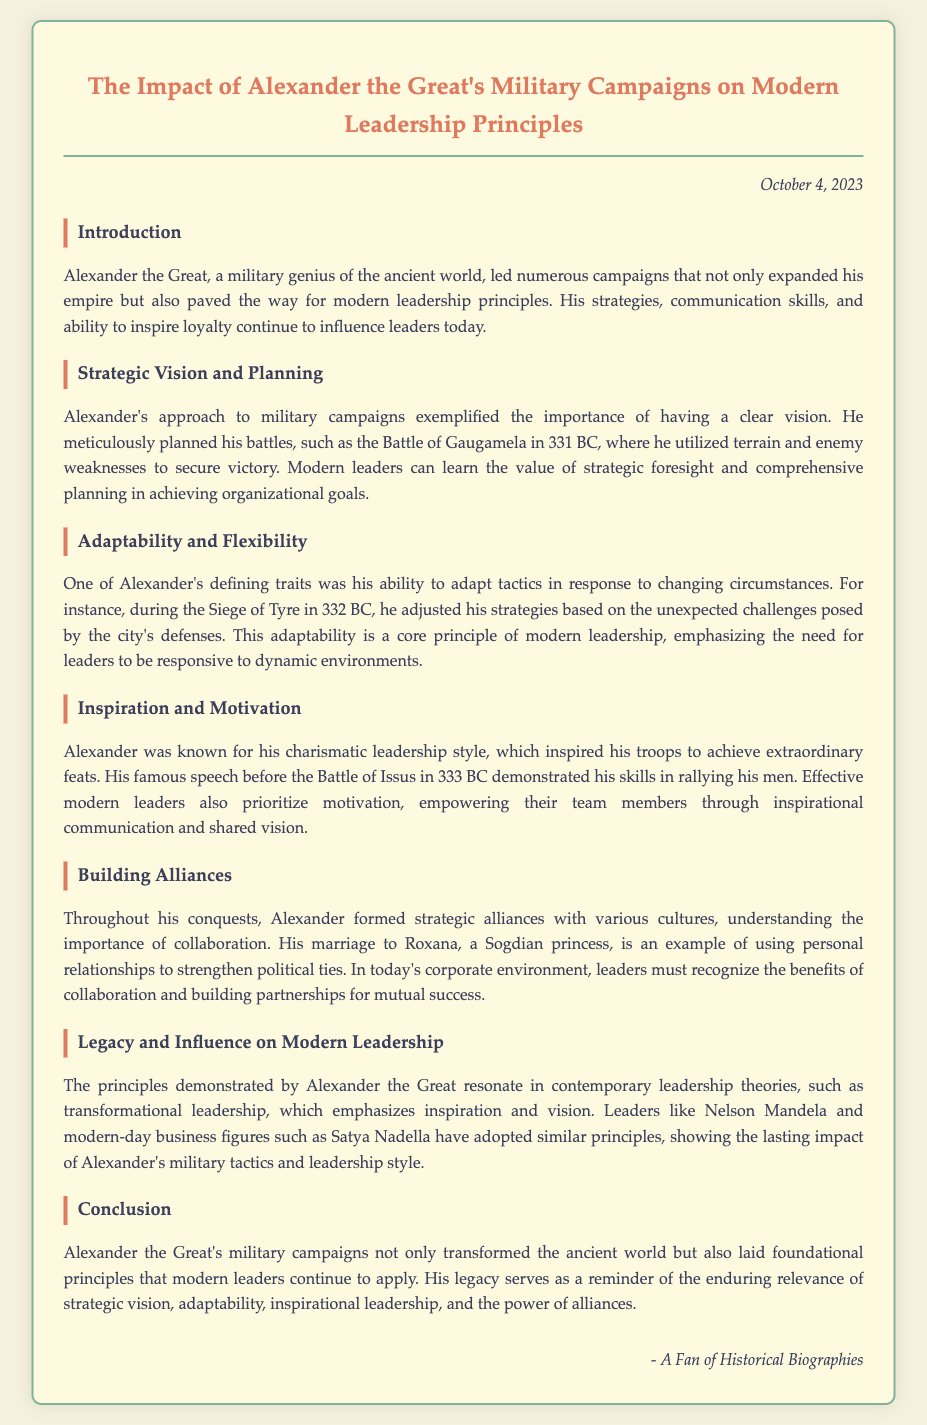What date was the memo written? The document states that it was written on October 4, 2023.
Answer: October 4, 2023 Who was known for his charismatic leadership style? The document mentions Alexander as the figure known for his charismatic leadership style.
Answer: Alexander What battle is highlighted for Alexander's strategic planning? The document references the Battle of Gaugamela as an example of strategic planning.
Answer: Battle of Gaugamela What trait exemplifies Alexander's approach to changing circumstances? The memo describes adaptability as a defining trait of Alexander's approach.
Answer: Adaptability Name one modern leader mentioned that adopted principles from Alexander. Nelson Mandela is mentioned as a modern leader who adopted similar principles.
Answer: Nelson Mandela What type of leadership is emphasized as a legacy of Alexander's principles? The document refers to transformational leadership as a contemporary reflection of Alexander's principles.
Answer: Transformational leadership In which year did Alexander conduct the Siege of Tyre? The document states that the Siege of Tyre occurred in 332 BC.
Answer: 332 BC What was a personal strategy used by Alexander to build alliances? The memo states that his marriage to Roxana was a strategy for strengthening political ties.
Answer: Marriage to Roxana What is the main subject of the memo? The document discusses Alexander the Great's military campaigns and their impact on modern leadership principles.
Answer: Impact of Alexander the Great's military campaigns on modern leadership principles 